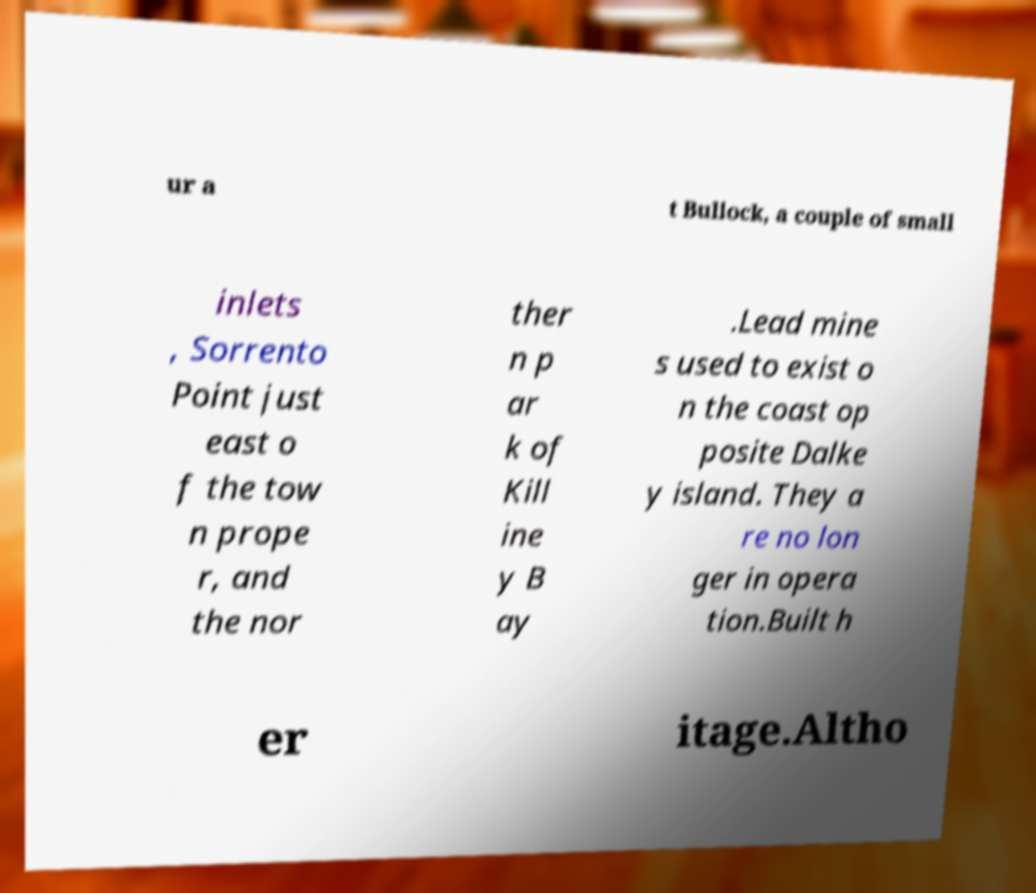There's text embedded in this image that I need extracted. Can you transcribe it verbatim? ur a t Bullock, a couple of small inlets , Sorrento Point just east o f the tow n prope r, and the nor ther n p ar k of Kill ine y B ay .Lead mine s used to exist o n the coast op posite Dalke y island. They a re no lon ger in opera tion.Built h er itage.Altho 